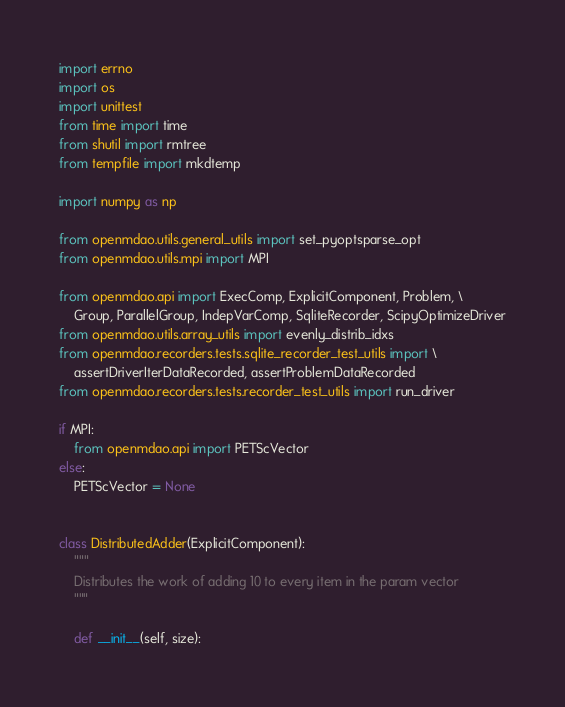<code> <loc_0><loc_0><loc_500><loc_500><_Python_>import errno
import os
import unittest
from time import time
from shutil import rmtree
from tempfile import mkdtemp

import numpy as np

from openmdao.utils.general_utils import set_pyoptsparse_opt
from openmdao.utils.mpi import MPI

from openmdao.api import ExecComp, ExplicitComponent, Problem, \
    Group, ParallelGroup, IndepVarComp, SqliteRecorder, ScipyOptimizeDriver
from openmdao.utils.array_utils import evenly_distrib_idxs
from openmdao.recorders.tests.sqlite_recorder_test_utils import \
    assertDriverIterDataRecorded, assertProblemDataRecorded
from openmdao.recorders.tests.recorder_test_utils import run_driver

if MPI:
    from openmdao.api import PETScVector
else:
    PETScVector = None


class DistributedAdder(ExplicitComponent):
    """
    Distributes the work of adding 10 to every item in the param vector
    """

    def __init__(self, size):</code> 